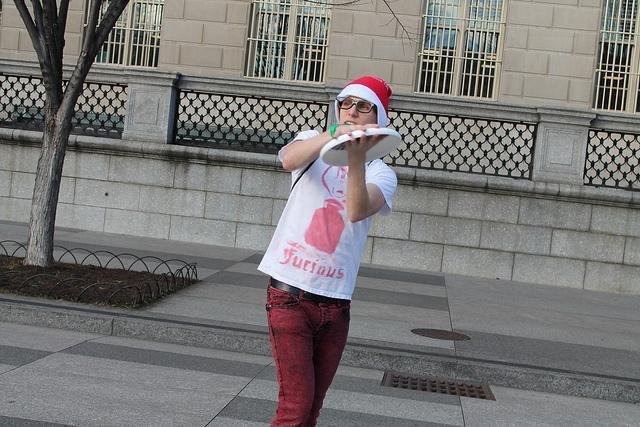How many red cars are driving on the road?
Give a very brief answer. 0. 